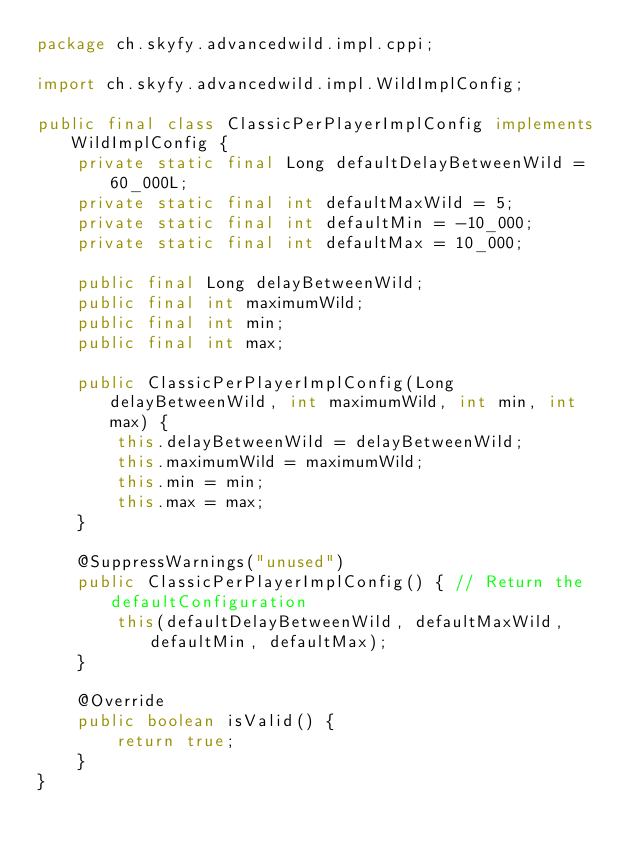<code> <loc_0><loc_0><loc_500><loc_500><_Java_>package ch.skyfy.advancedwild.impl.cppi;

import ch.skyfy.advancedwild.impl.WildImplConfig;

public final class ClassicPerPlayerImplConfig implements WildImplConfig {
    private static final Long defaultDelayBetweenWild = 60_000L;
    private static final int defaultMaxWild = 5;
    private static final int defaultMin = -10_000;
    private static final int defaultMax = 10_000;

    public final Long delayBetweenWild;
    public final int maximumWild;
    public final int min;
    public final int max;

    public ClassicPerPlayerImplConfig(Long delayBetweenWild, int maximumWild, int min, int max) {
        this.delayBetweenWild = delayBetweenWild;
        this.maximumWild = maximumWild;
        this.min = min;
        this.max = max;
    }

    @SuppressWarnings("unused")
    public ClassicPerPlayerImplConfig() { // Return the defaultConfiguration
        this(defaultDelayBetweenWild, defaultMaxWild, defaultMin, defaultMax);
    }

    @Override
    public boolean isValid() {
        return true;
    }
}
</code> 